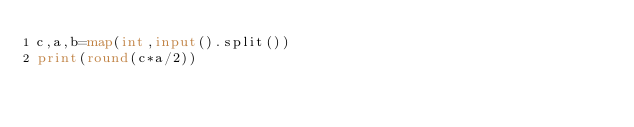<code> <loc_0><loc_0><loc_500><loc_500><_Python_>c,a,b=map(int,input().split())
print(round(c*a/2))</code> 